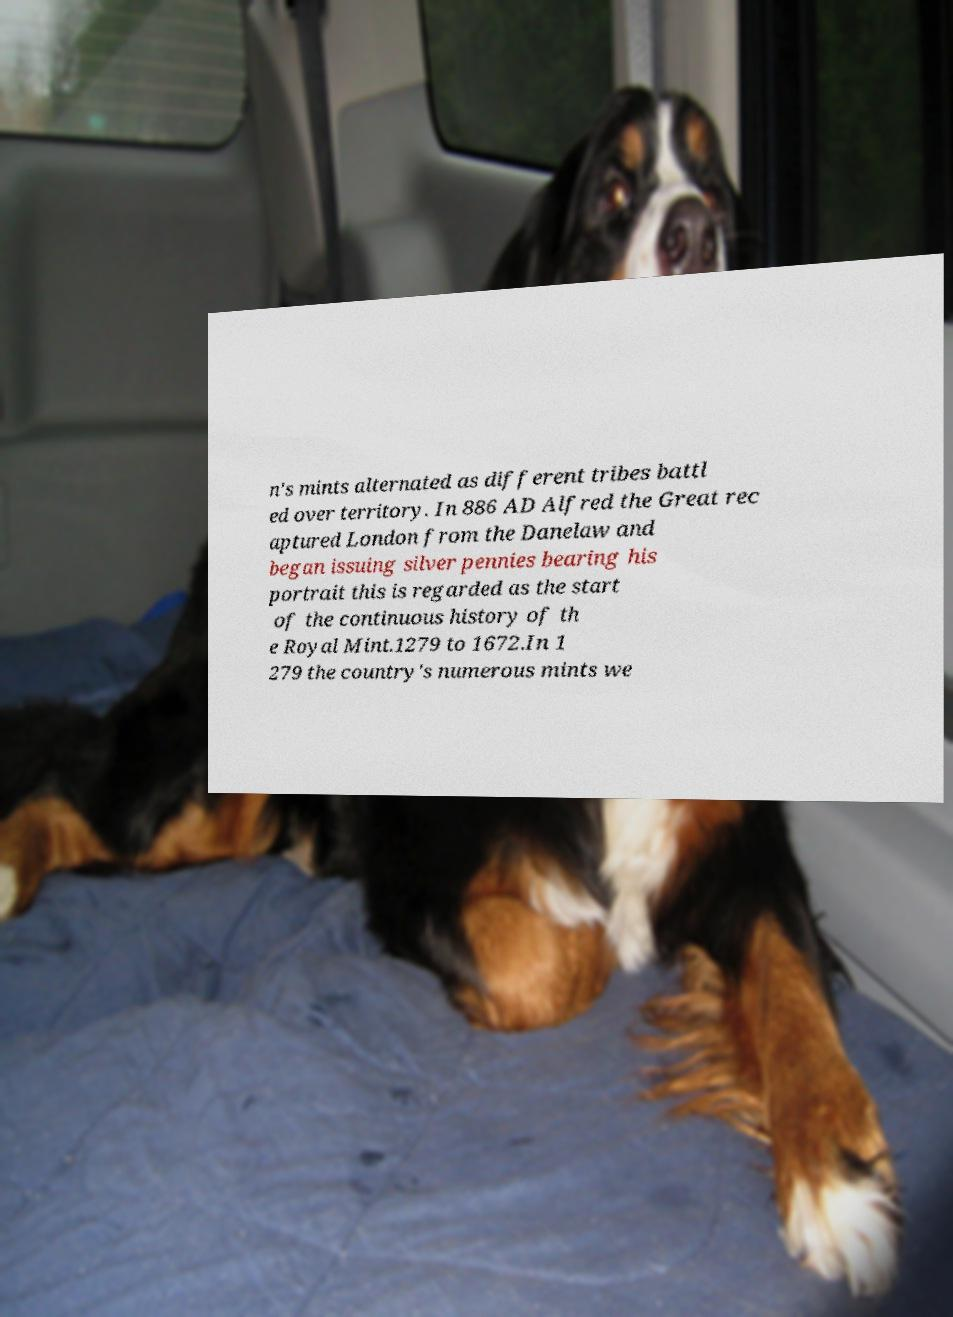For documentation purposes, I need the text within this image transcribed. Could you provide that? n's mints alternated as different tribes battl ed over territory. In 886 AD Alfred the Great rec aptured London from the Danelaw and began issuing silver pennies bearing his portrait this is regarded as the start of the continuous history of th e Royal Mint.1279 to 1672.In 1 279 the country's numerous mints we 